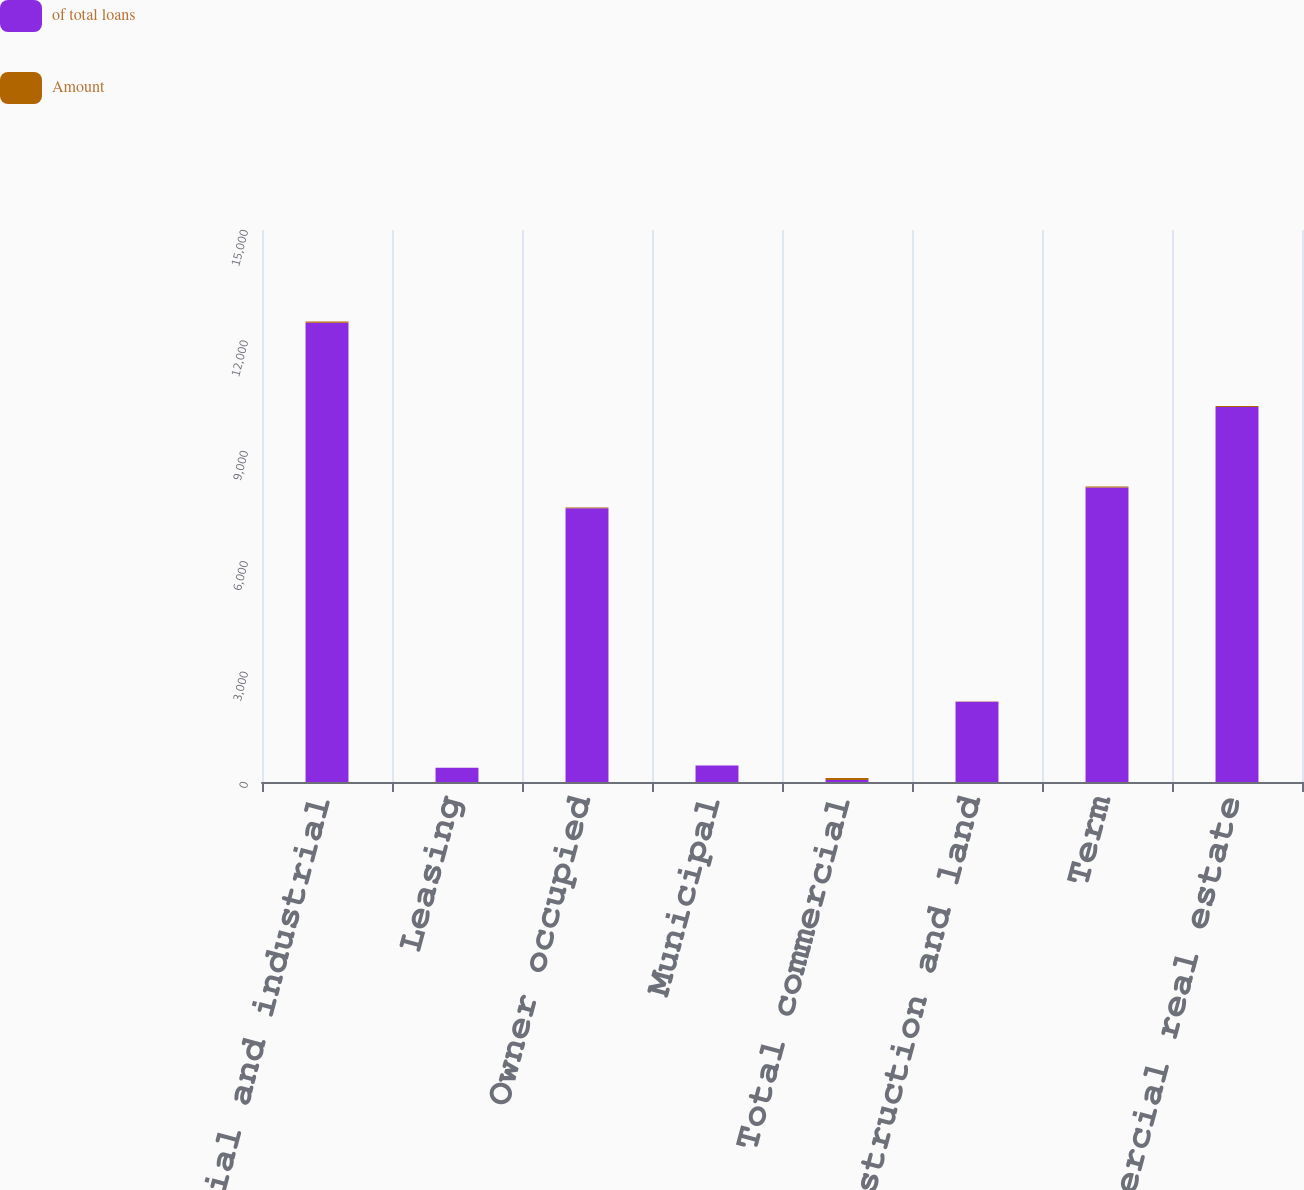Convert chart to OTSL. <chart><loc_0><loc_0><loc_500><loc_500><stacked_bar_chart><ecel><fcel>Commercial and industrial<fcel>Leasing<fcel>Owner occupied<fcel>Municipal<fcel>Total commercial<fcel>Construction and land<fcel>Term<fcel>Total commercial real estate<nl><fcel>of total loans<fcel>12481<fcel>388<fcel>7437<fcel>449<fcel>53.2<fcel>2183<fcel>8006<fcel>10189<nl><fcel>Amount<fcel>32<fcel>1<fcel>19<fcel>1.2<fcel>53.2<fcel>5.6<fcel>20.5<fcel>26.1<nl></chart> 